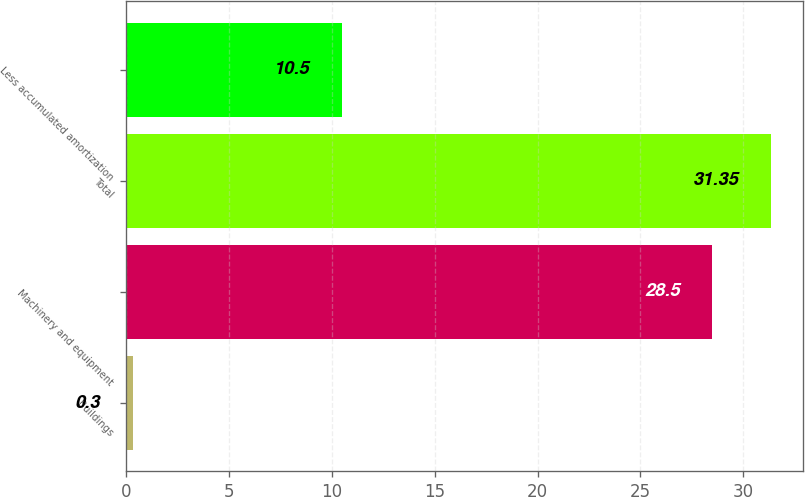<chart> <loc_0><loc_0><loc_500><loc_500><bar_chart><fcel>Buildings<fcel>Machinery and equipment<fcel>Total<fcel>Less accumulated amortization<nl><fcel>0.3<fcel>28.5<fcel>31.35<fcel>10.5<nl></chart> 